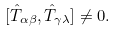<formula> <loc_0><loc_0><loc_500><loc_500>[ \hat { T } _ { \alpha \beta } , \hat { T } _ { \gamma \lambda } ] \neq 0 .</formula> 